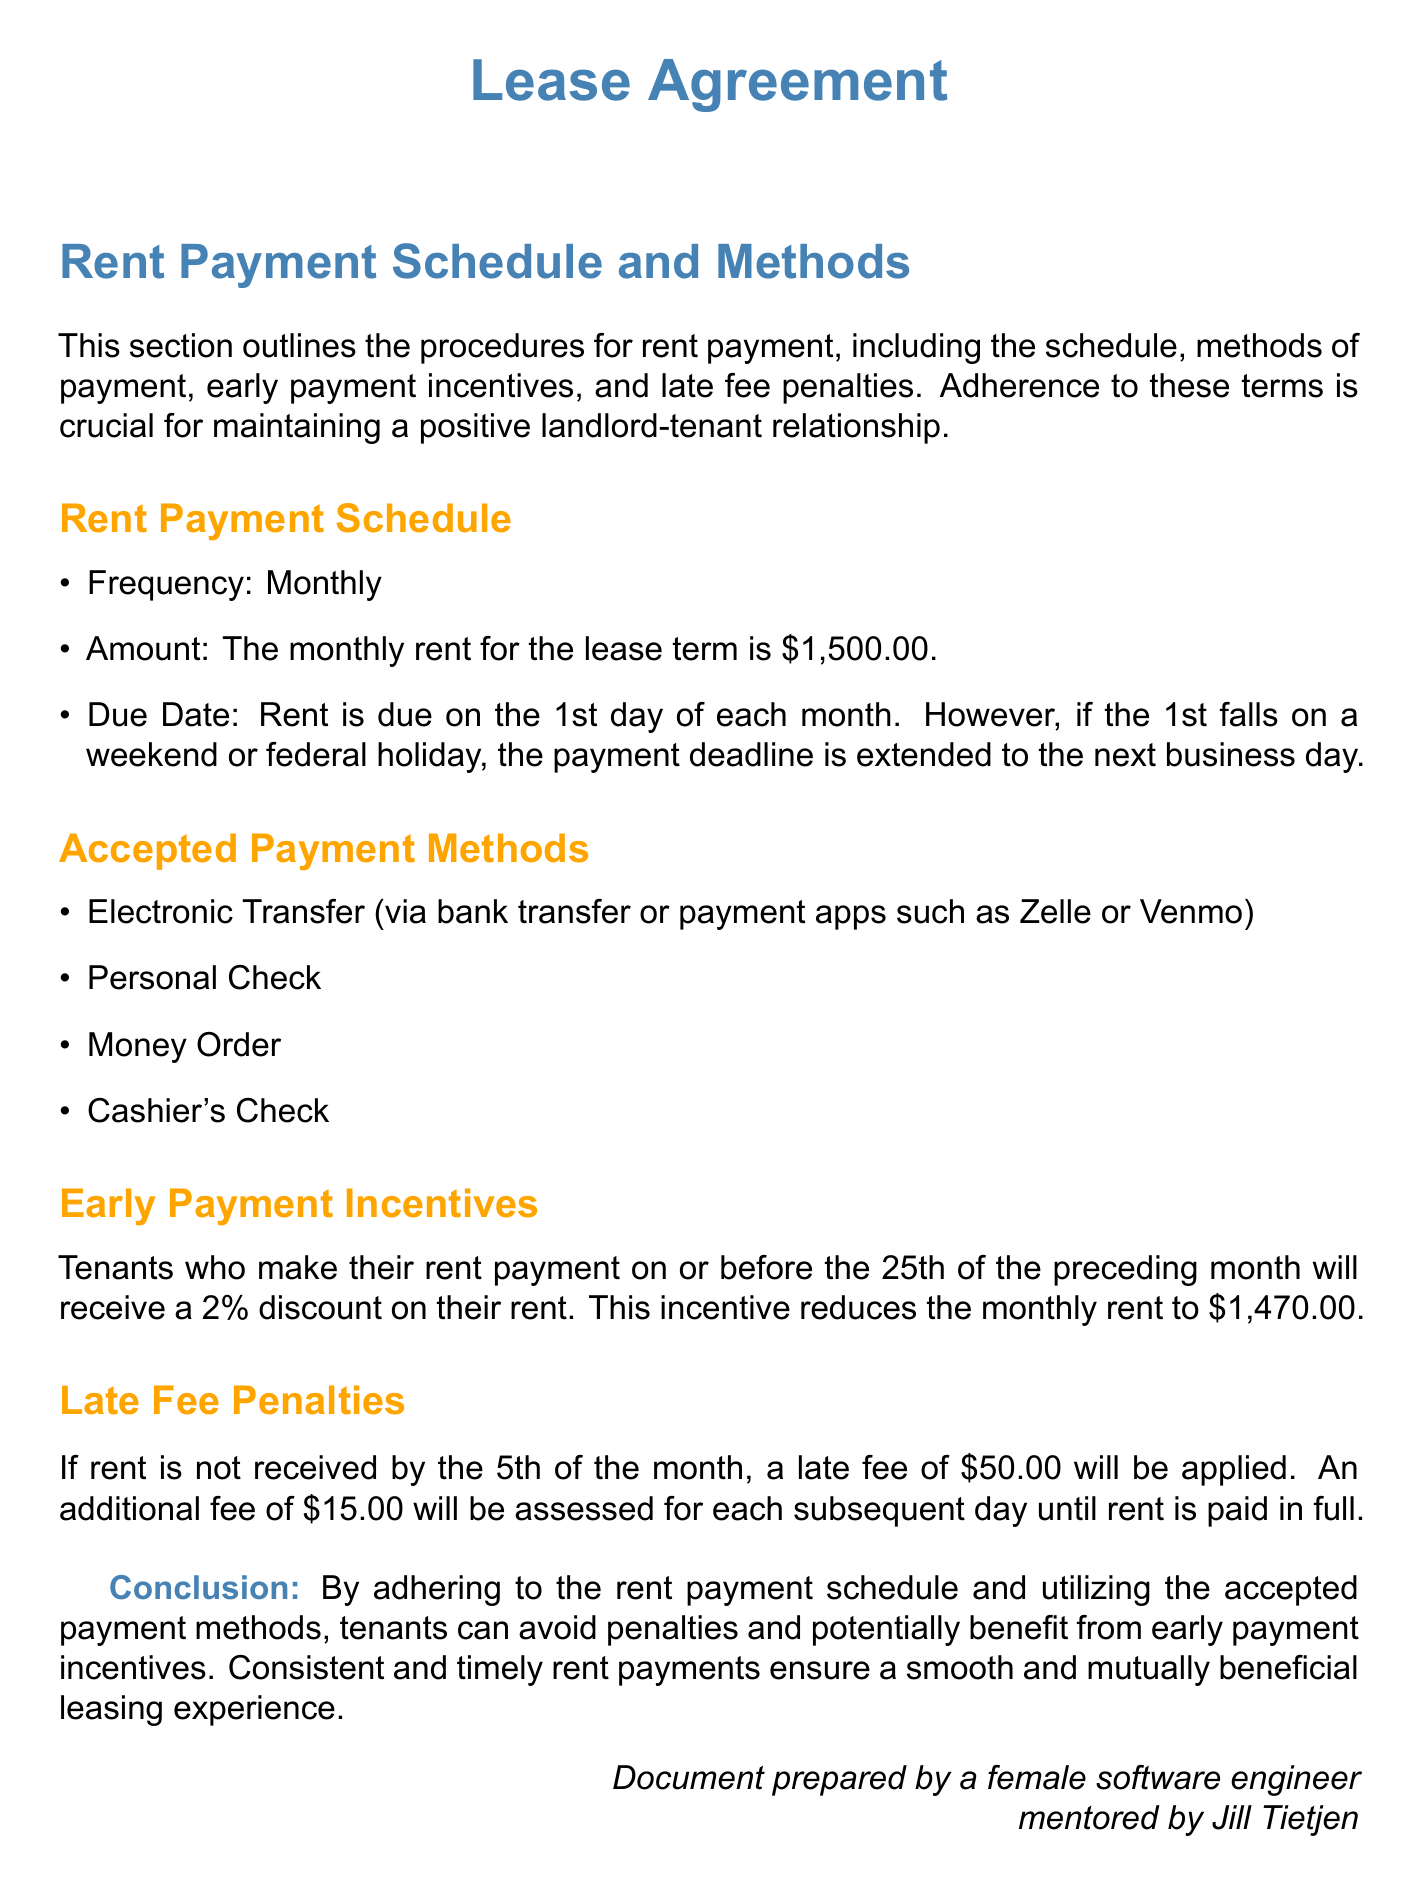What is the monthly rent amount? The document states the monthly rent for the lease term is $1,500.00.
Answer: $1,500.00 When is rent due? Rent is due on the 1st day of each month, with a provision for weekends and holidays.
Answer: 1st day of each month What happens if rent is not received by the 5th? The document specifies a late fee of $50.00 will be applied if rent is not received by the 5th.
Answer: $50.00 What discount is offered for early payment? Tenants who pay on or before the 25th of the preceding month receive a 2% discount.
Answer: 2% What is the reduced rent amount for early payment? The early payment incentive reduces the monthly rent from $1,500.00 to $1,470.00.
Answer: $1,470.00 Which payment method is mentioned as an electronic transfer? The document lists bank transfer or payment apps such as Zelle or Venmo as acceptable methods.
Answer: Zelle or Venmo How much is the additional fee charged for each subsequent day after the initial late fee? An additional fee of $15.00 will be assessed for each day until rent is paid in full.
Answer: $15.00 What is the structure type of this document? The document is specifically a Lease Agreement outlining payment schedules and methods.
Answer: Lease Agreement How are penalties structured for late payments? The document outlines that a late fee is first $50.00 and then an additional fee of $15.00 for each day late.
Answer: $50.00 plus $15.00 per day 